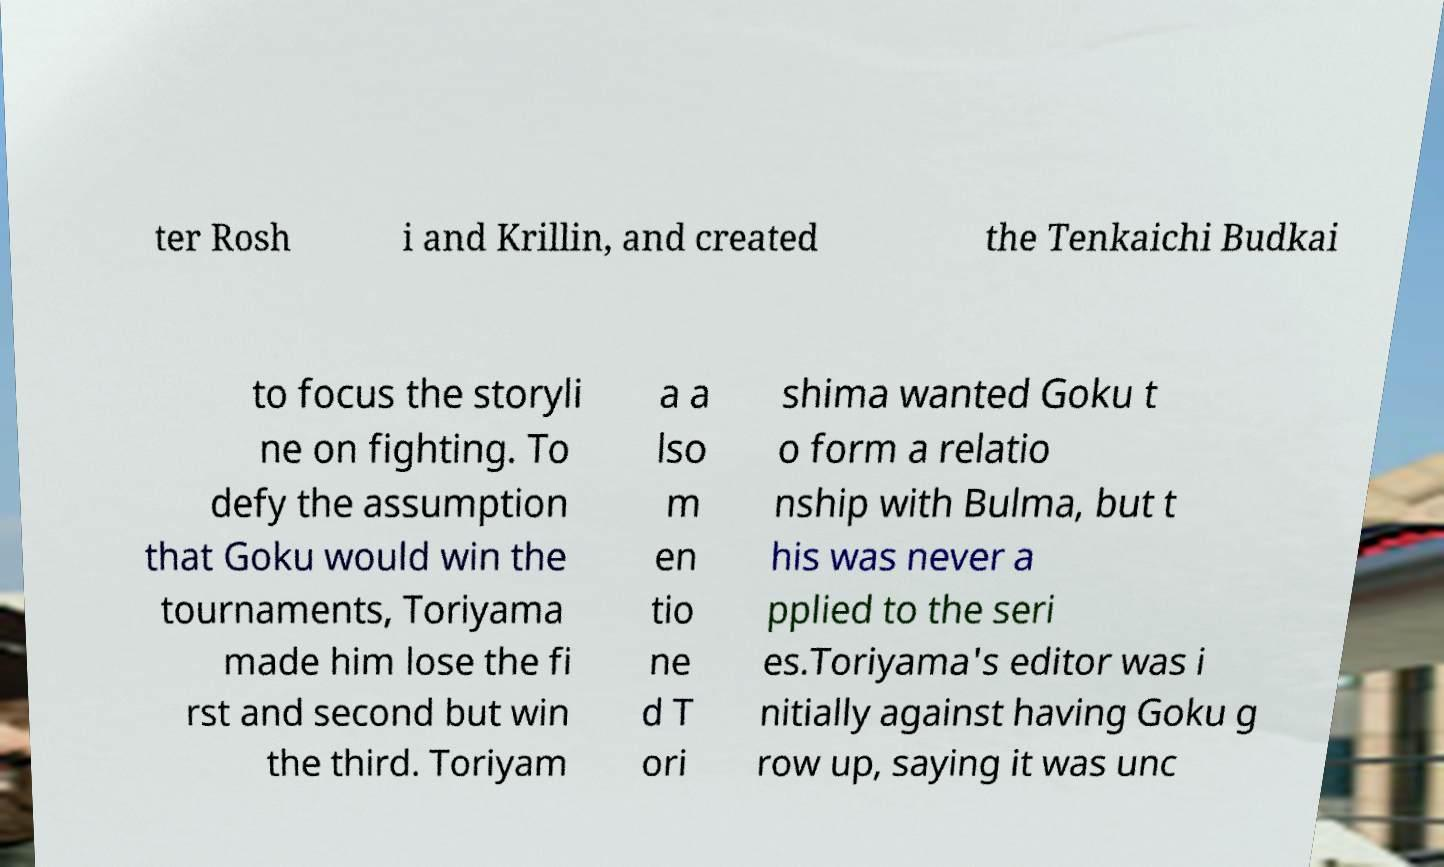Can you accurately transcribe the text from the provided image for me? ter Rosh i and Krillin, and created the Tenkaichi Budkai to focus the storyli ne on fighting. To defy the assumption that Goku would win the tournaments, Toriyama made him lose the fi rst and second but win the third. Toriyam a a lso m en tio ne d T ori shima wanted Goku t o form a relatio nship with Bulma, but t his was never a pplied to the seri es.Toriyama's editor was i nitially against having Goku g row up, saying it was unc 